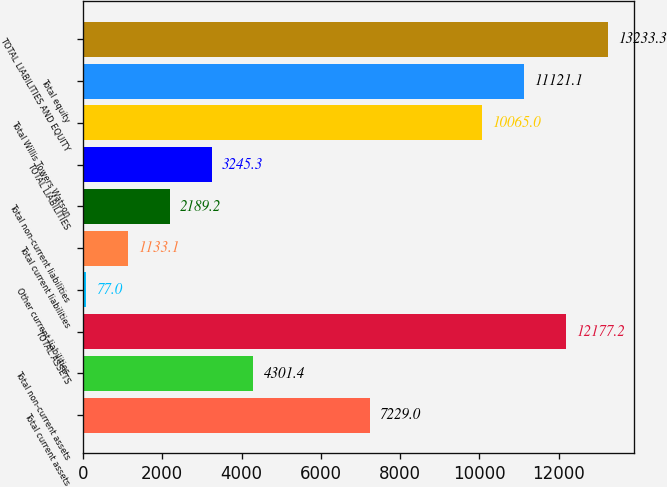<chart> <loc_0><loc_0><loc_500><loc_500><bar_chart><fcel>Total current assets<fcel>Total non-current assets<fcel>TOTAL ASSETS<fcel>Other current liabilities<fcel>Total current liabilities<fcel>Total non-current liabilities<fcel>TOTAL LIABILITIES<fcel>Total Willis Towers Watson<fcel>Total equity<fcel>TOTAL LIABILITIES AND EQUITY<nl><fcel>7229<fcel>4301.4<fcel>12177.2<fcel>77<fcel>1133.1<fcel>2189.2<fcel>3245.3<fcel>10065<fcel>11121.1<fcel>13233.3<nl></chart> 